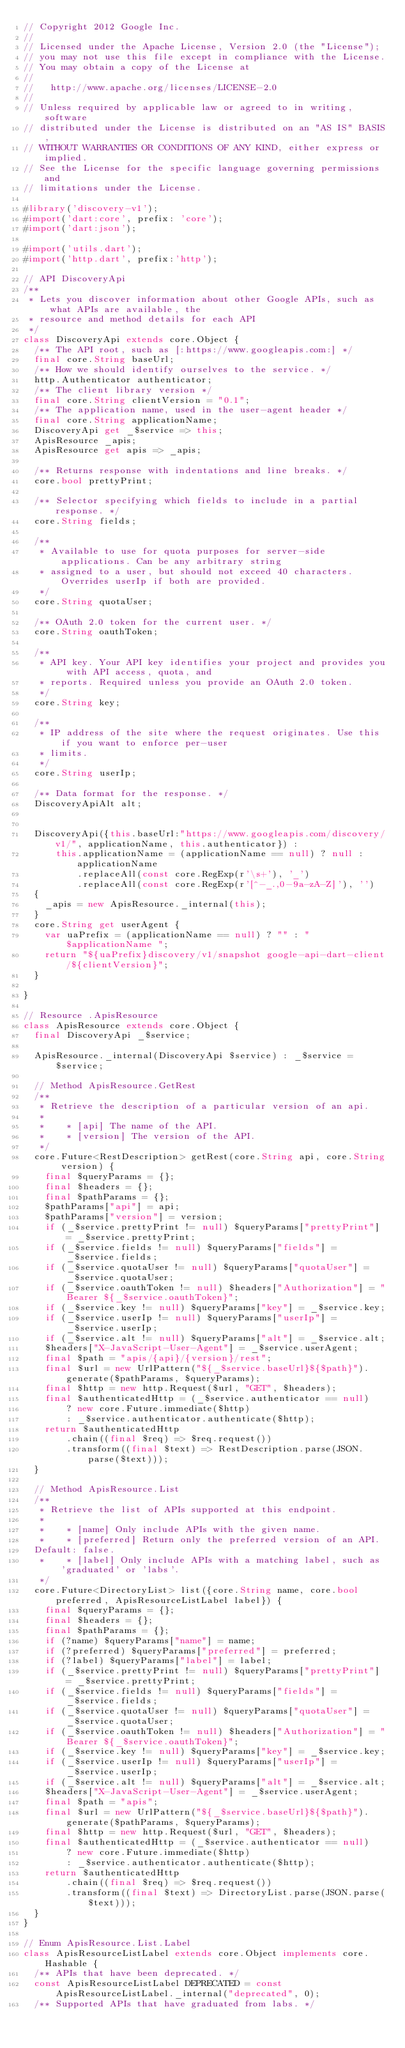Convert code to text. <code><loc_0><loc_0><loc_500><loc_500><_Dart_>// Copyright 2012 Google Inc.
//
// Licensed under the Apache License, Version 2.0 (the "License");
// you may not use this file except in compliance with the License.
// You may obtain a copy of the License at
//
//   http://www.apache.org/licenses/LICENSE-2.0
//
// Unless required by applicable law or agreed to in writing, software
// distributed under the License is distributed on an "AS IS" BASIS,
// WITHOUT WARRANTIES OR CONDITIONS OF ANY KIND, either express or implied.
// See the License for the specific language governing permissions and
// limitations under the License.

#library('discovery-v1');
#import('dart:core', prefix: 'core');
#import('dart:json');

#import('utils.dart');
#import('http.dart', prefix:'http');

// API DiscoveryApi
/**
 * Lets you discover information about other Google APIs, such as what APIs are available, the
 * resource and method details for each API
 */
class DiscoveryApi extends core.Object {
  /** The API root, such as [:https://www.googleapis.com:] */
  final core.String baseUrl;
  /** How we should identify ourselves to the service. */
  http.Authenticator authenticator;
  /** The client library version */
  final core.String clientVersion = "0.1";
  /** The application name, used in the user-agent header */
  final core.String applicationName;
  DiscoveryApi get _$service => this;
  ApisResource _apis;
  ApisResource get apis => _apis;
  
  /** Returns response with indentations and line breaks. */
  core.bool prettyPrint;

  /** Selector specifying which fields to include in a partial response. */
  core.String fields;

  /**
   * Available to use for quota purposes for server-side applications. Can be any arbitrary string
   * assigned to a user, but should not exceed 40 characters. Overrides userIp if both are provided.
   */
  core.String quotaUser;

  /** OAuth 2.0 token for the current user. */
  core.String oauthToken;

  /**
   * API key. Your API key identifies your project and provides you with API access, quota, and
   * reports. Required unless you provide an OAuth 2.0 token.
   */
  core.String key;

  /**
   * IP address of the site where the request originates. Use this if you want to enforce per-user
   * limits.
   */
  core.String userIp;

  /** Data format for the response. */
  DiscoveryApiAlt alt;


  DiscoveryApi({this.baseUrl:"https://www.googleapis.com/discovery/v1/", applicationName, this.authenticator}) :
      this.applicationName = (applicationName == null) ? null : applicationName
          .replaceAll(const core.RegExp(r'\s+'), '_')
          .replaceAll(const core.RegExp(r'[^-_.,0-9a-zA-Z]'), '')
  { 
    _apis = new ApisResource._internal(this);
  }
  core.String get userAgent {
    var uaPrefix = (applicationName == null) ? "" : "$applicationName ";
    return "${uaPrefix}discovery/v1/snapshot google-api-dart-client/${clientVersion}";
  }

}

// Resource .ApisResource
class ApisResource extends core.Object {
  final DiscoveryApi _$service;
  
  ApisResource._internal(DiscoveryApi $service) : _$service = $service;

  // Method ApisResource.GetRest
  /**
   * Retrieve the description of a particular version of an api.
   *
   *    * [api] The name of the API.
   *    * [version] The version of the API.
   */
  core.Future<RestDescription> getRest(core.String api, core.String version) {
    final $queryParams = {};
    final $headers = {};
    final $pathParams = {};
    $pathParams["api"] = api;
    $pathParams["version"] = version;
    if (_$service.prettyPrint != null) $queryParams["prettyPrint"] = _$service.prettyPrint;
    if (_$service.fields != null) $queryParams["fields"] = _$service.fields;
    if (_$service.quotaUser != null) $queryParams["quotaUser"] = _$service.quotaUser;
    if (_$service.oauthToken != null) $headers["Authorization"] = "Bearer ${_$service.oauthToken}";
    if (_$service.key != null) $queryParams["key"] = _$service.key;
    if (_$service.userIp != null) $queryParams["userIp"] = _$service.userIp;
    if (_$service.alt != null) $queryParams["alt"] = _$service.alt;
    $headers["X-JavaScript-User-Agent"] = _$service.userAgent;
    final $path = "apis/{api}/{version}/rest";
    final $url = new UrlPattern("${_$service.baseUrl}${$path}").generate($pathParams, $queryParams);
    final $http = new http.Request($url, "GET", $headers);
    final $authenticatedHttp = (_$service.authenticator == null)
        ? new core.Future.immediate($http)
        : _$service.authenticator.authenticate($http);
    return $authenticatedHttp
        .chain((final $req) => $req.request())
        .transform((final $text) => RestDescription.parse(JSON.parse($text)));
  }

  // Method ApisResource.List
  /**
   * Retrieve the list of APIs supported at this endpoint.
   *
   *    * [name] Only include APIs with the given name.
   *    * [preferred] Return only the preferred version of an API.
  Default: false.
   *    * [label] Only include APIs with a matching label, such as 'graduated' or 'labs'.
   */
  core.Future<DirectoryList> list({core.String name, core.bool preferred, ApisResourceListLabel label}) {
    final $queryParams = {};
    final $headers = {};
    final $pathParams = {};
    if (?name) $queryParams["name"] = name;
    if (?preferred) $queryParams["preferred"] = preferred;
    if (?label) $queryParams["label"] = label;
    if (_$service.prettyPrint != null) $queryParams["prettyPrint"] = _$service.prettyPrint;
    if (_$service.fields != null) $queryParams["fields"] = _$service.fields;
    if (_$service.quotaUser != null) $queryParams["quotaUser"] = _$service.quotaUser;
    if (_$service.oauthToken != null) $headers["Authorization"] = "Bearer ${_$service.oauthToken}";
    if (_$service.key != null) $queryParams["key"] = _$service.key;
    if (_$service.userIp != null) $queryParams["userIp"] = _$service.userIp;
    if (_$service.alt != null) $queryParams["alt"] = _$service.alt;
    $headers["X-JavaScript-User-Agent"] = _$service.userAgent;
    final $path = "apis";
    final $url = new UrlPattern("${_$service.baseUrl}${$path}").generate($pathParams, $queryParams);
    final $http = new http.Request($url, "GET", $headers);
    final $authenticatedHttp = (_$service.authenticator == null)
        ? new core.Future.immediate($http)
        : _$service.authenticator.authenticate($http);
    return $authenticatedHttp
        .chain((final $req) => $req.request())
        .transform((final $text) => DirectoryList.parse(JSON.parse($text)));
  }
}

// Enum ApisResource.List.Label
class ApisResourceListLabel extends core.Object implements core.Hashable {
  /** APIs that have been deprecated. */
  const ApisResourceListLabel DEPRECATED = const ApisResourceListLabel._internal("deprecated", 0);
  /** Supported APIs that have graduated from labs. */</code> 